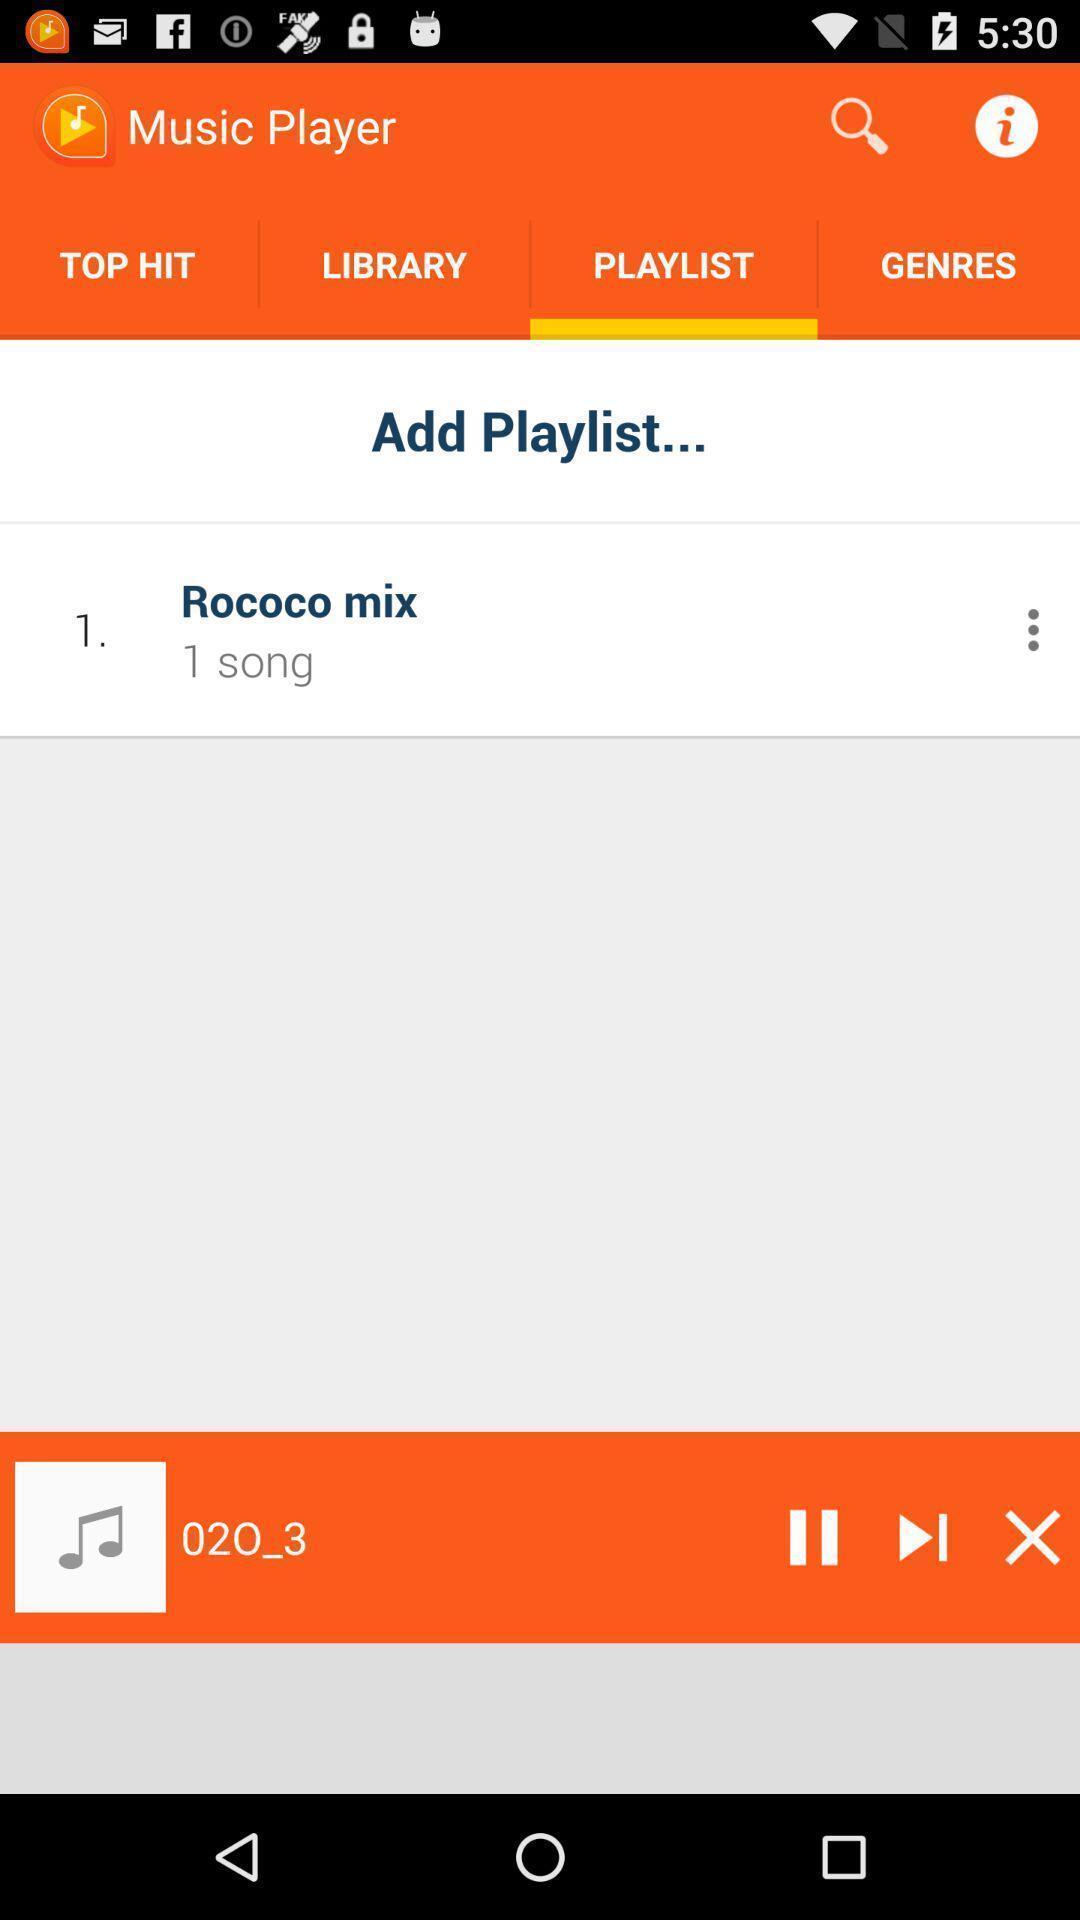Give me a narrative description of this picture. Screen page of a playlist in a music app. 